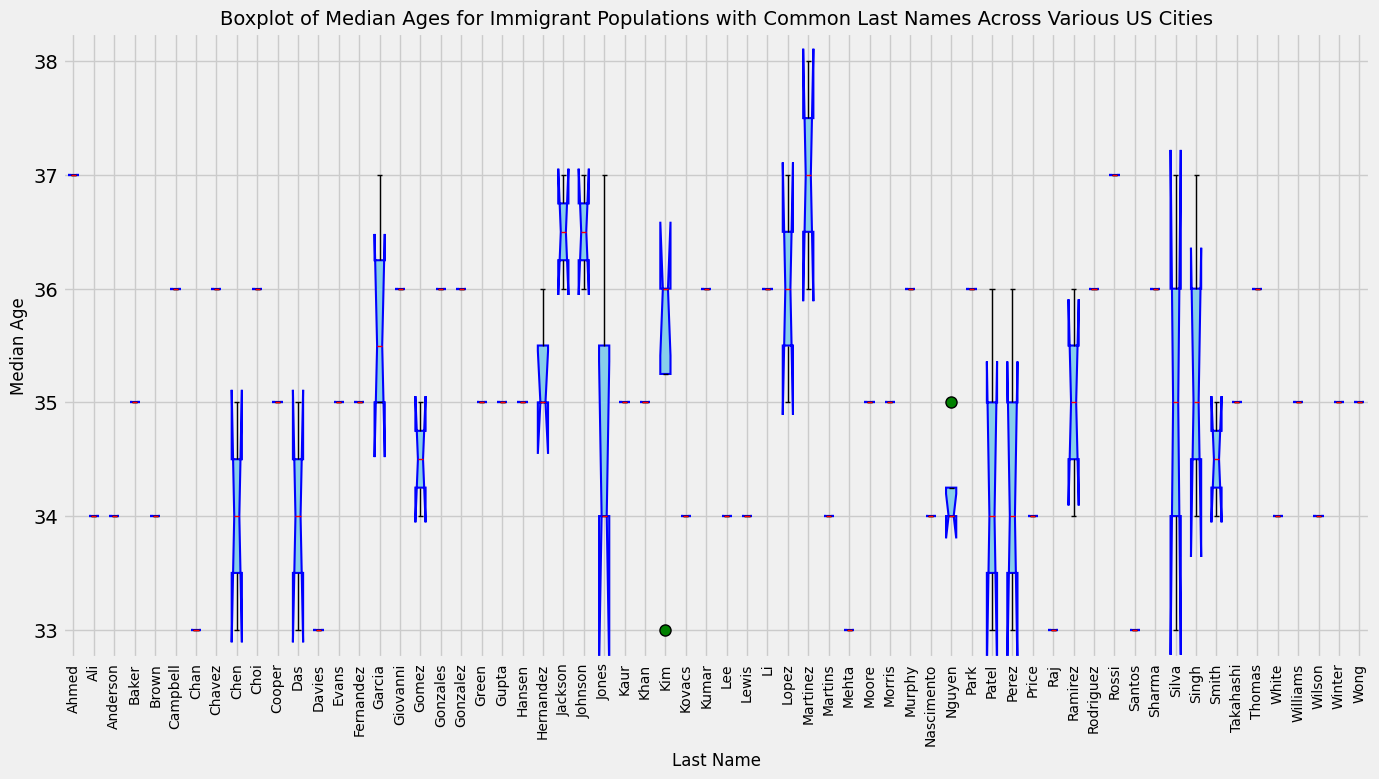Which last name has the highest median age? By inspecting the boxplot, identify the box with the highest median line, which is highlighted in red. This line represents the median age.
Answer: Martinez What is the interquartile range (IQR) for people with the last name 'Nguyen'? The IQR is the difference between the upper and lower quartiles. For the last name 'Nguyen', identify the upper and lower quartiles, and then subtract the lower quartile from the upper quartile.
Answer: 6 (IQR: 40 - 34) Is the median age for 'Garcia' higher than 'Smith'? Compare the median lines (in red) for 'Garcia' and 'Smith' in the boxplot to see which is higher.
Answer: Yes Which last name has the shortest interquartile range? Determine which box in the boxplot has the smallest distance between the upper and lower quartiles, representing the shortest IQR.
Answer: Singh (IQR: 39 - 34) How many last names have a median age of 36? Count the number of boxes where the red median line aligns with the median age of 36.
Answer: 12 Which last names have an upper quartile that reaches up to 45 years old? Look for boxes where the top of the box (upper quartile) reaches up to 45 on the Y-axis.
Answer: Garcia, Ahmed, Newark, Peoria Are there any last names where the entire interquartile range falls below 35 years old? Check for boxes entirely below the 35-year mark, ensuring both quartile lines are under 35.
Answer: No Does 'Kim' have a higher upper quartile than 'Evans'? Compare the upper quartile (top of the box) of 'Kim' with that of 'Evans' to see which is higher.
Answer: Yes What is the median age difference between 'Davies' and 'Jackson'? Determine the median ages of both last names and subtract the smaller value from the larger one.
Answer: 3 (Median ages: 36 - 33) Which last name has the broadest spread of ages (i.e., maximum range from lower to upper quartile)? Identify the box that has the largest vertical distance between its lower and upper quartiles, indicating the broadest spread.
Answer: Ahmed, Newark, Peoria (Range: 17) 